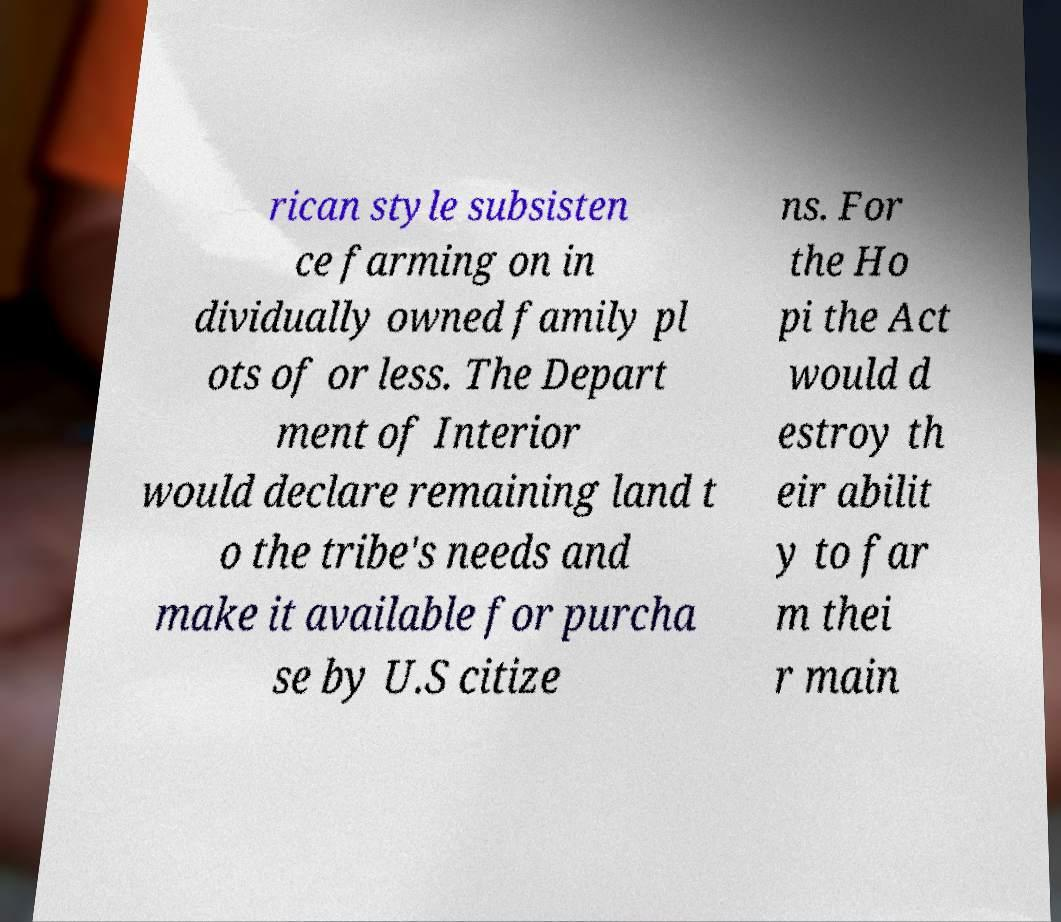What messages or text are displayed in this image? I need them in a readable, typed format. rican style subsisten ce farming on in dividually owned family pl ots of or less. The Depart ment of Interior would declare remaining land t o the tribe's needs and make it available for purcha se by U.S citize ns. For the Ho pi the Act would d estroy th eir abilit y to far m thei r main 